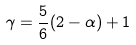Convert formula to latex. <formula><loc_0><loc_0><loc_500><loc_500>\gamma = \frac { 5 } { 6 } ( 2 - \alpha ) + 1</formula> 